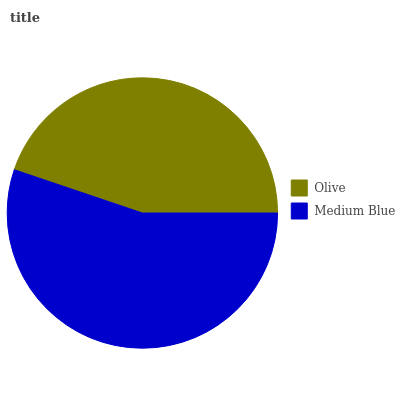Is Olive the minimum?
Answer yes or no. Yes. Is Medium Blue the maximum?
Answer yes or no. Yes. Is Medium Blue the minimum?
Answer yes or no. No. Is Medium Blue greater than Olive?
Answer yes or no. Yes. Is Olive less than Medium Blue?
Answer yes or no. Yes. Is Olive greater than Medium Blue?
Answer yes or no. No. Is Medium Blue less than Olive?
Answer yes or no. No. Is Medium Blue the high median?
Answer yes or no. Yes. Is Olive the low median?
Answer yes or no. Yes. Is Olive the high median?
Answer yes or no. No. Is Medium Blue the low median?
Answer yes or no. No. 